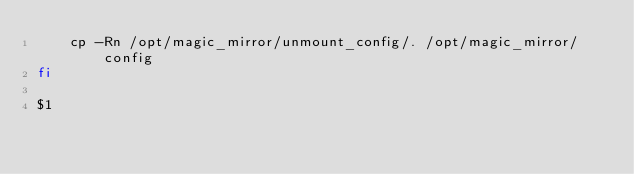<code> <loc_0><loc_0><loc_500><loc_500><_Bash_>    cp -Rn /opt/magic_mirror/unmount_config/. /opt/magic_mirror/config
fi

$1
</code> 